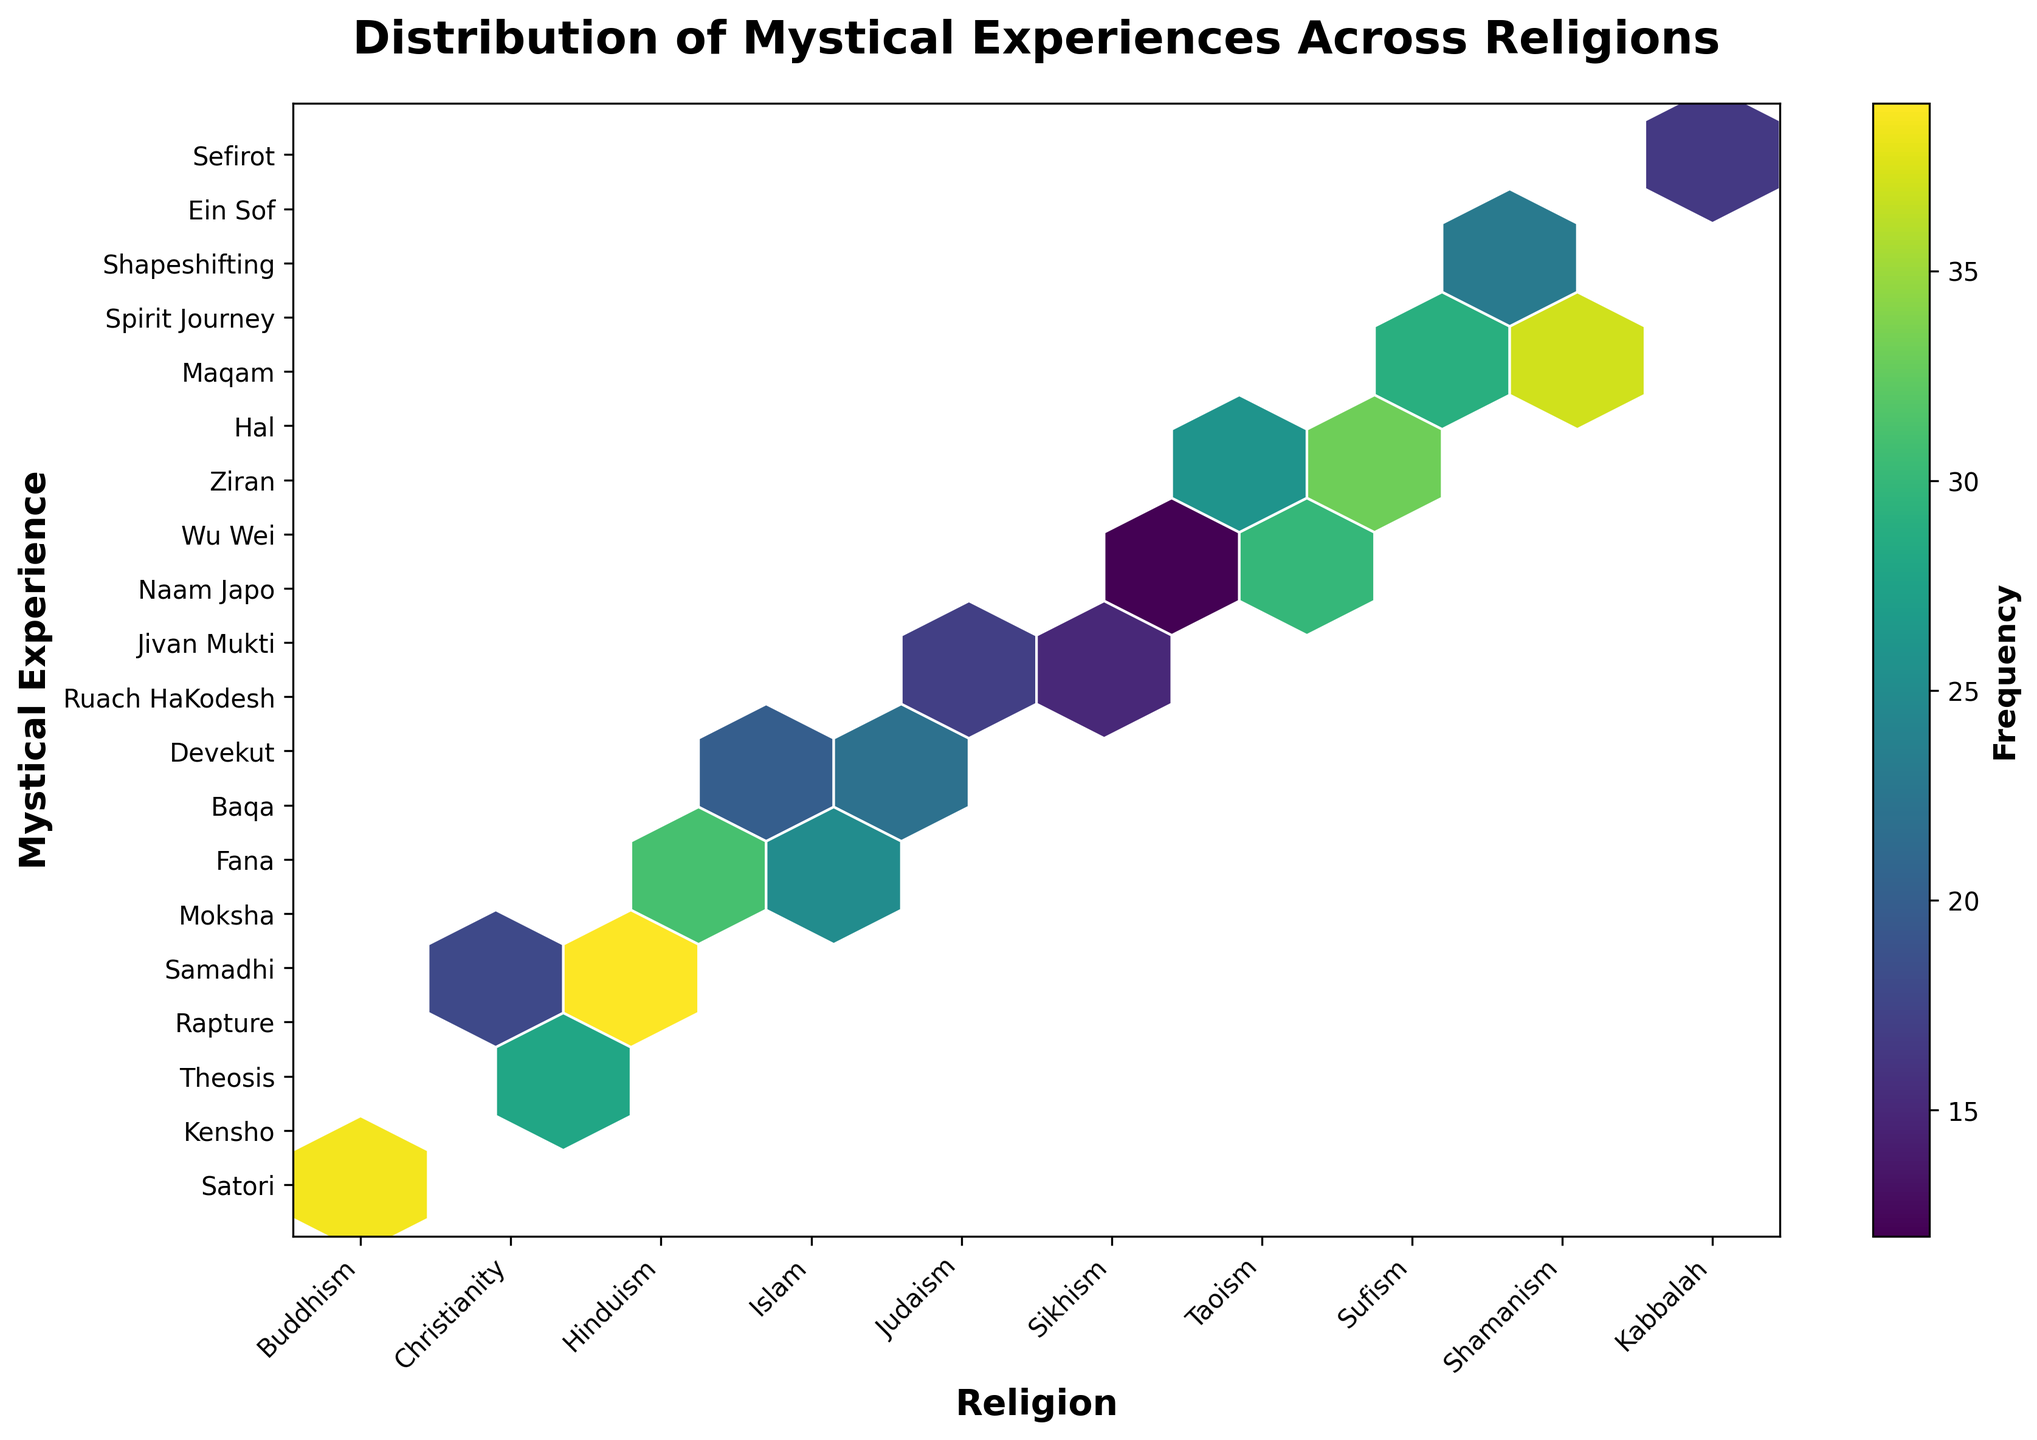What is the title of the hexbin plot? The title is placed above the hexbin plot and often summarized in a larger or bolder font.
Answer: Distribution of Mystical Experiences Across Religions Which religion has the highest number of recorded mystical experiences? To answer this, compare the total frequency values for each religion by summing up their associated mystical experiences frequencies.
Answer: Buddhism Which mystical experience in Christianity has a higher frequency, Theosis or Rapture? Look at the positions on the hexbin plot corresponding to Christianity on the x-axis and compare the frequencies indicated by the hex colors or labels.
Answer: Theosis How do the frequencies of Wu Wei in Taoism and Spirit Journey in Shamanism compare? Check the hexbin colors corresponding to these particular mystical experiences and compare the levels of darkness, which represent frequency.
Answer: Spirit Journey Which mystical experiences have the lowest frequency across all religions? Examine the hexbin plot to find the hexes with the lightest color, indicating the lowest frequency.
Answer: Naam Japo and Ruach HaKodesh How does the number of mystical experiences in Islam compare to those in Sufism? Sum up the frequencies of mystical experiences in each religion and compare the totals. Islam: Fana (25) + Baqa (20) = 45, Sufism: Hal (33) + Maqam (29) = 62.
Answer: Islam has fewer What is the most common mystical experience in Hinduism and its frequency? Locate Hinduism on the x-axis and determine the mystical experience with the highest frequency by observing the darkest hex or checking the frequency labels.
Answer: Samadhi, 39 Which religion has the most diverse set of high-frequency mystical experiences? Identify the religion with the highest number of dark hexes (indicating high frequency) for different mystical experiences.
Answer: Hinduism How does the distribution of mystical experiences in Judaism compare with those in Kabbalah? Count and compare the colors (frequencies) of the mystical experiences listed under Judaism and Kabbalah, respectively. Judaism: Devekut (22) + Ruach HaKodesh (17) = 39, Kabbalah: Ein Sof (19) + Sefirot (14) = 33.
Answer: Judaism has a higher overall frequency What is the average frequency of the mystical experiences listed under Tent Religion? (e.g., Buddhism) Sum the frequencies of all mystical experiences for that religion and divide by the number of mystical experiences. (Satori: 42, Kensho: 35) Sum: 77, Number of experiences: 2. Average = 77/2 = 38.5
Answer: 38.5 